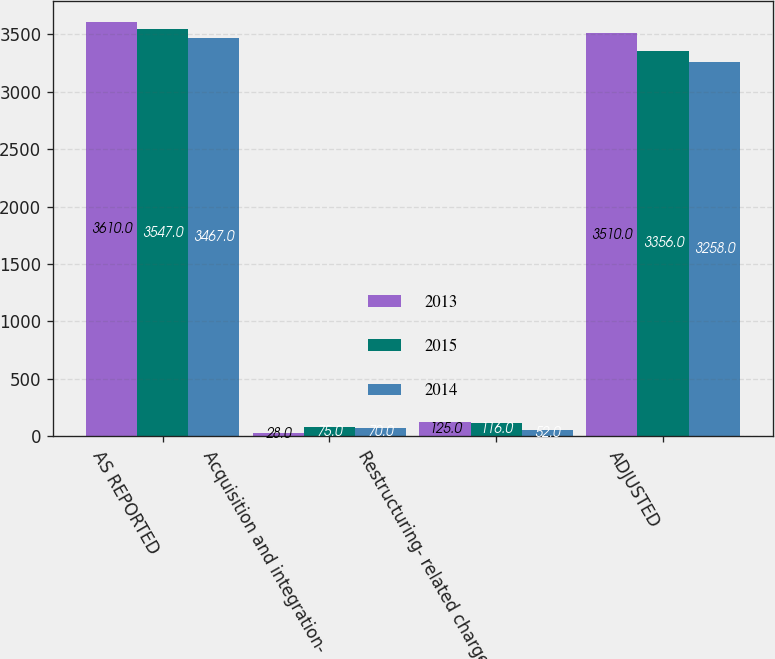Convert chart to OTSL. <chart><loc_0><loc_0><loc_500><loc_500><stacked_bar_chart><ecel><fcel>AS REPORTED<fcel>Acquisition and integration-<fcel>Restructuring- related charges<fcel>ADJUSTED<nl><fcel>2013<fcel>3610<fcel>28<fcel>125<fcel>3510<nl><fcel>2015<fcel>3547<fcel>75<fcel>116<fcel>3356<nl><fcel>2014<fcel>3467<fcel>70<fcel>52<fcel>3258<nl></chart> 